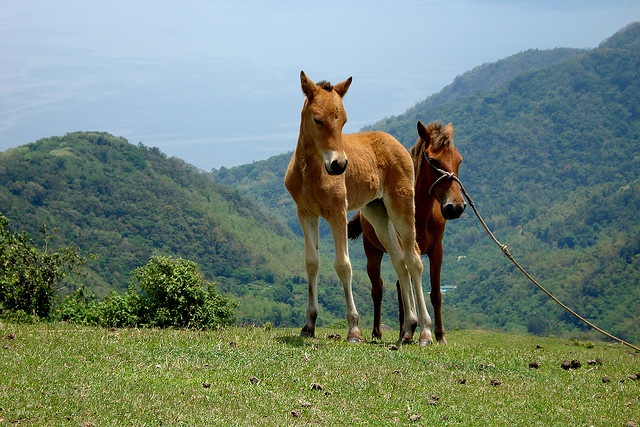Describe the objects in this image and their specific colors. I can see horse in lavender, maroon, olive, and black tones and horse in lavender, black, teal, maroon, and brown tones in this image. 